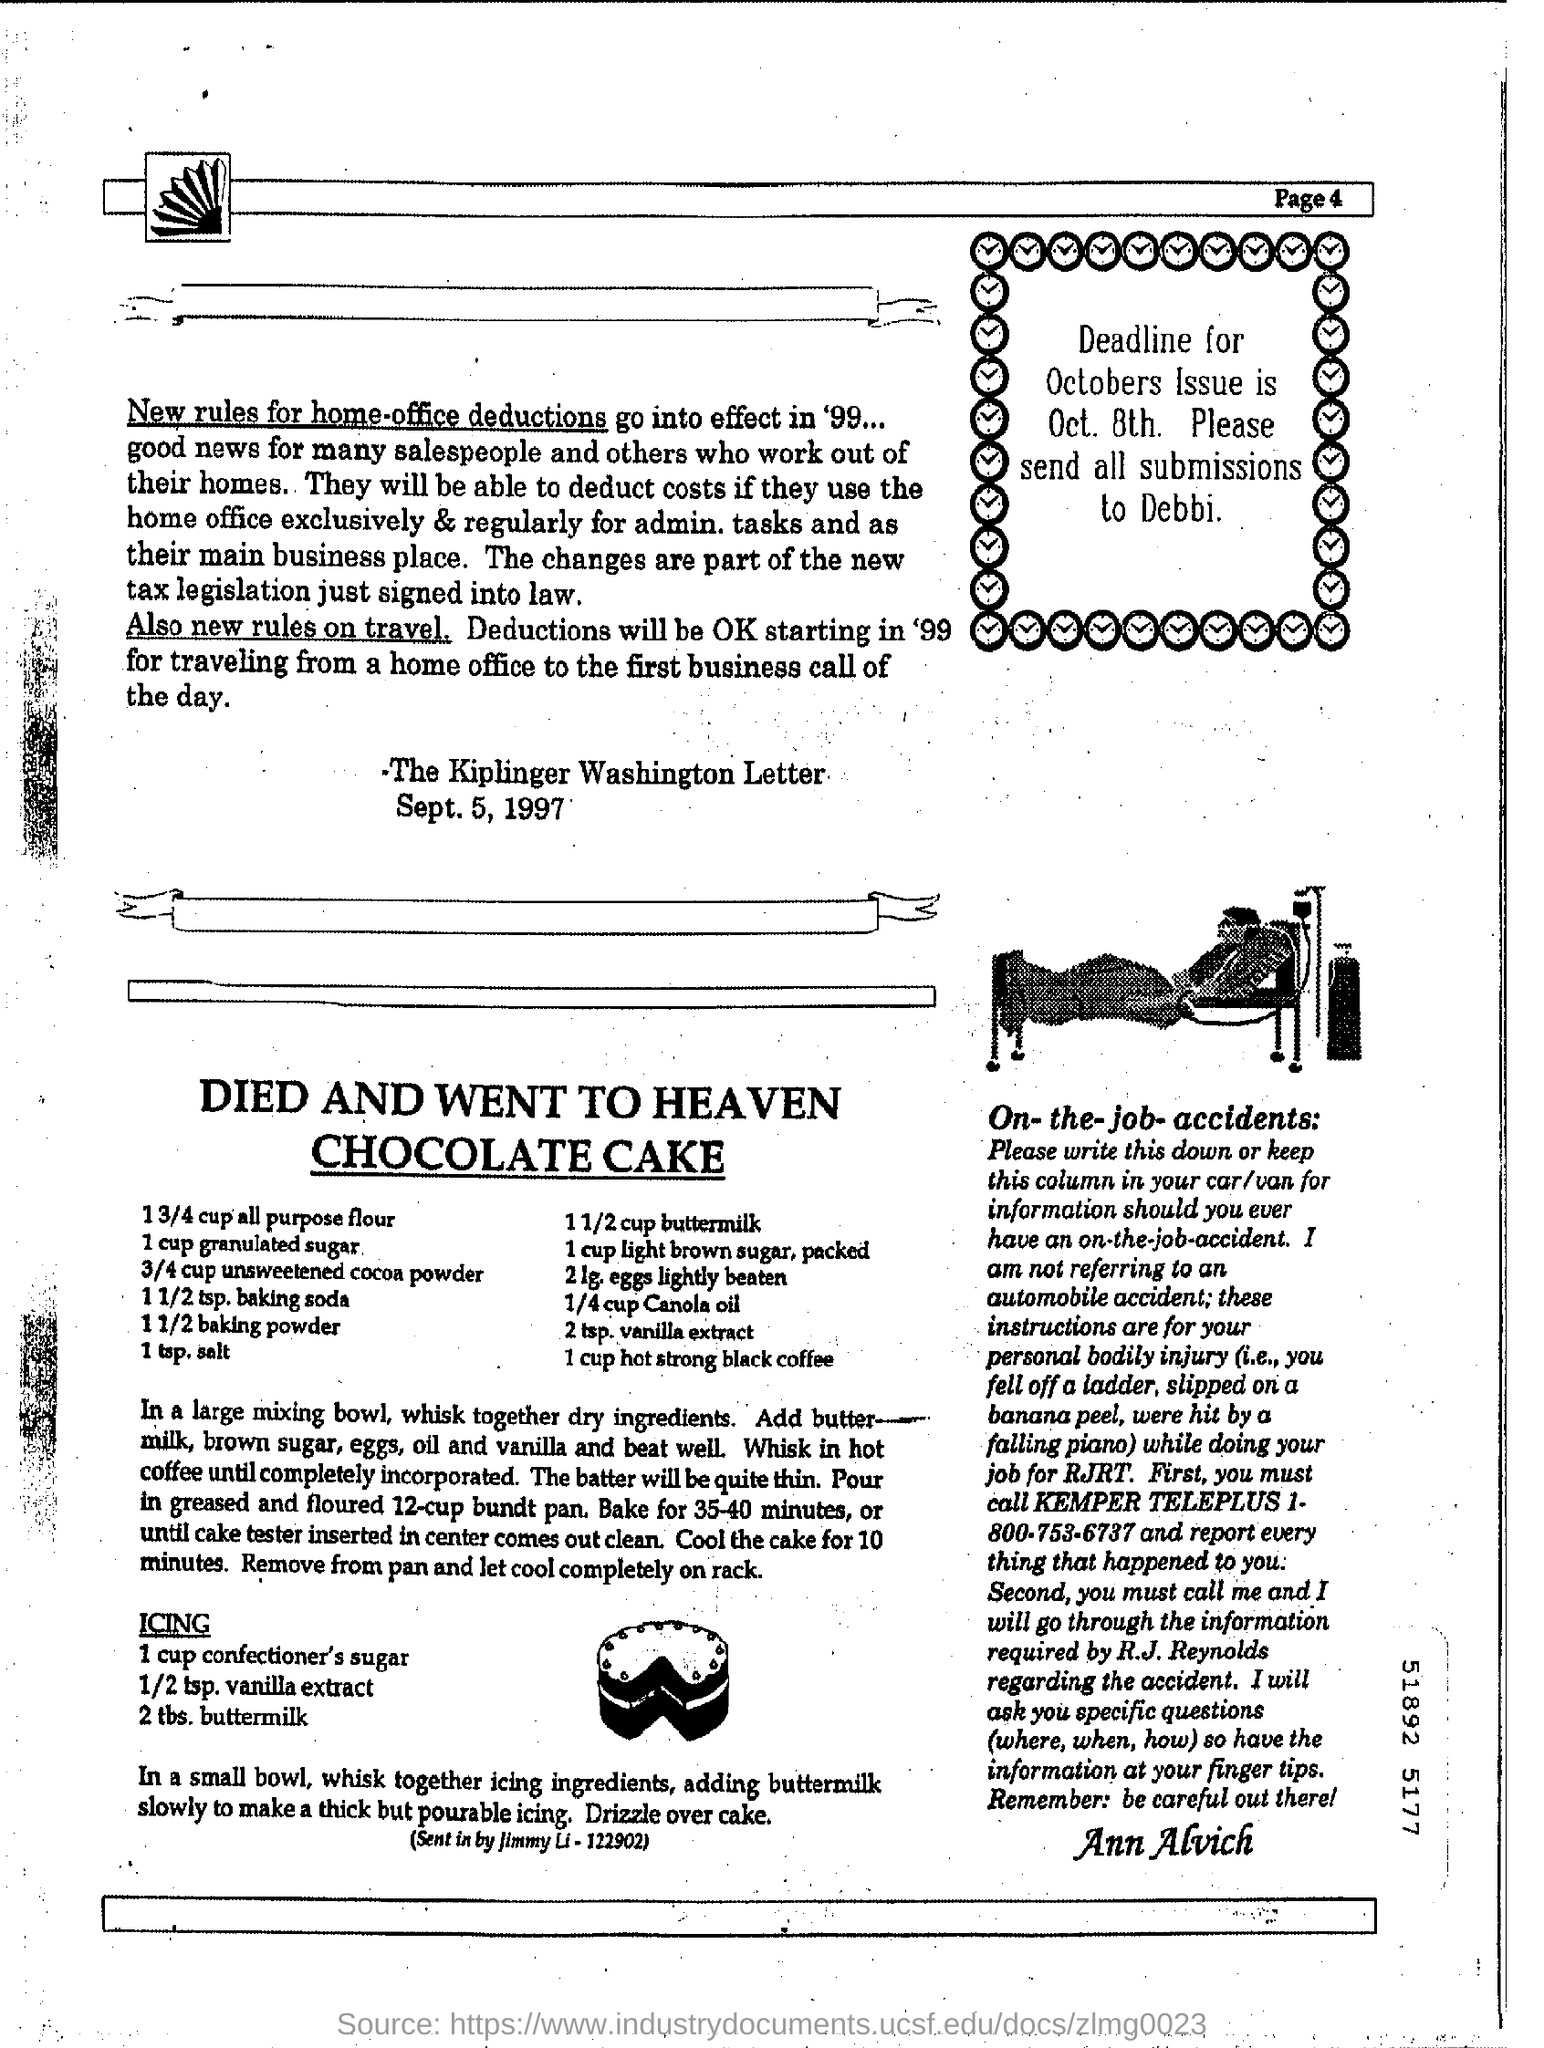Mention the page number at top right corner of the page ?
Keep it short and to the point. Page 4. 